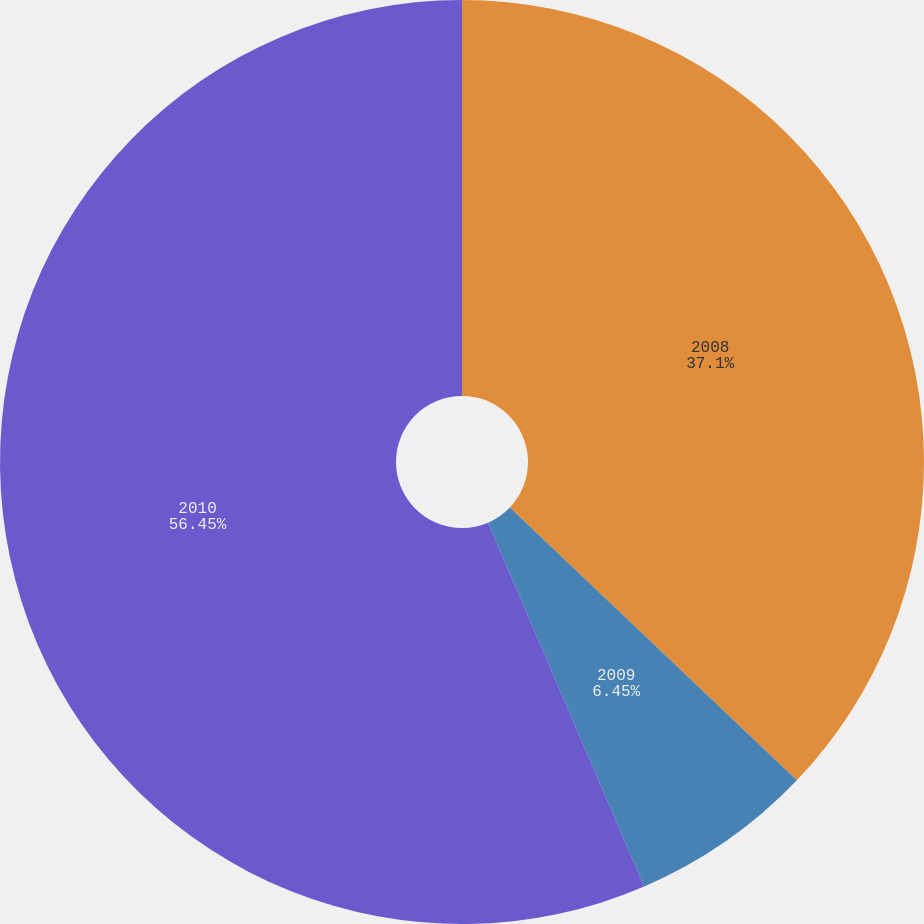Convert chart to OTSL. <chart><loc_0><loc_0><loc_500><loc_500><pie_chart><fcel>2008<fcel>2009<fcel>2010<nl><fcel>37.1%<fcel>6.45%<fcel>56.45%<nl></chart> 